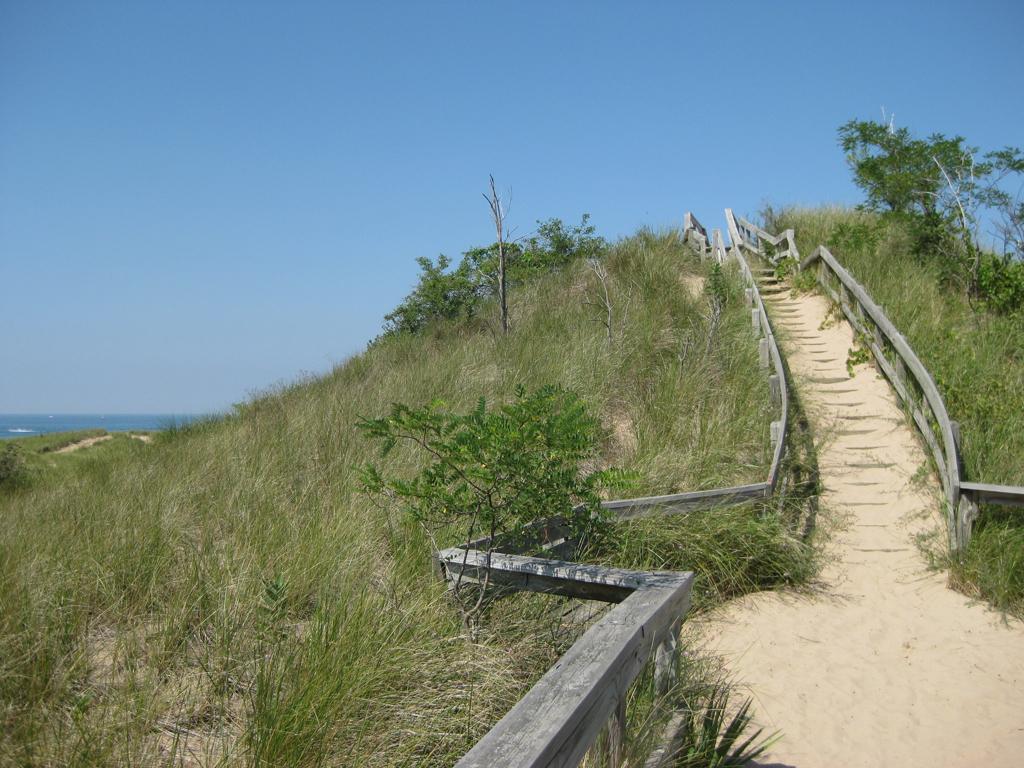In one or two sentences, can you explain what this image depicts? In this picture I can see plants and grass on the ground. I can see water in the back and a blue sky and I can see wooden fence on the both sides of the path. 